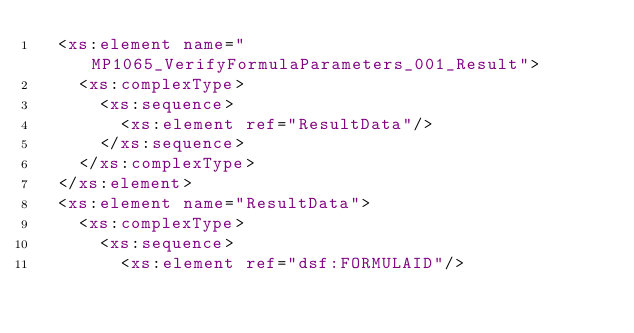<code> <loc_0><loc_0><loc_500><loc_500><_XML_>	<xs:element name="MP1065_VerifyFormulaParameters_001_Result">
		<xs:complexType>
			<xs:sequence>
				<xs:element ref="ResultData"/>
			</xs:sequence>
		</xs:complexType>
	</xs:element>
	<xs:element name="ResultData">
		<xs:complexType>
			<xs:sequence>
				<xs:element ref="dsf:FORMULAID"/></code> 